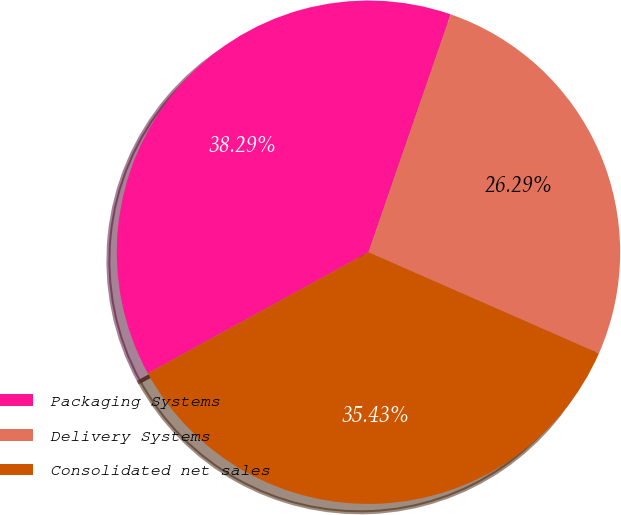Convert chart to OTSL. <chart><loc_0><loc_0><loc_500><loc_500><pie_chart><fcel>Packaging Systems<fcel>Delivery Systems<fcel>Consolidated net sales<nl><fcel>38.29%<fcel>26.29%<fcel>35.43%<nl></chart> 